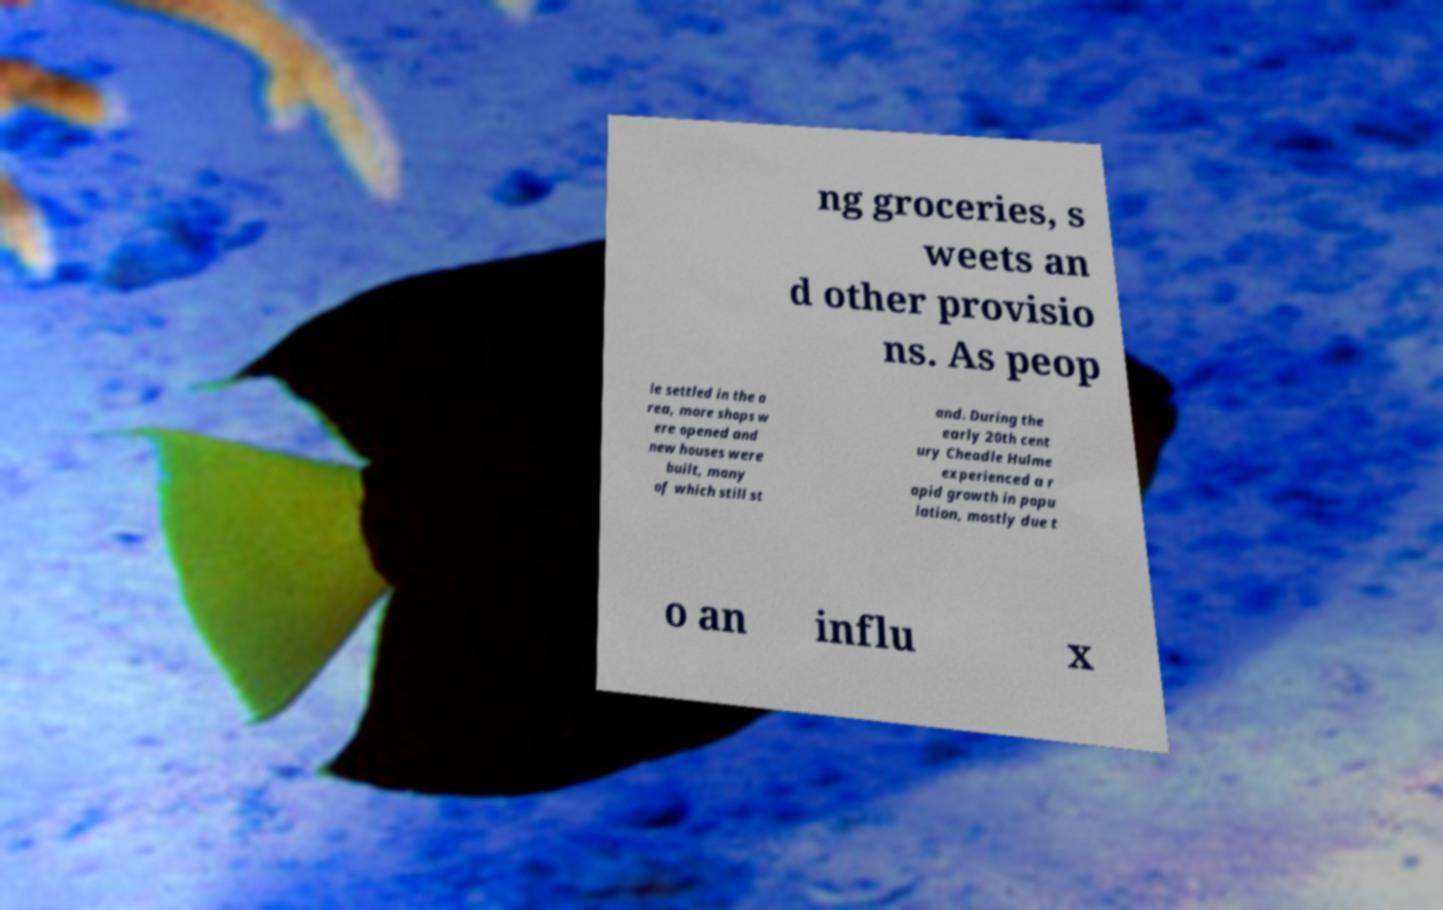There's text embedded in this image that I need extracted. Can you transcribe it verbatim? ng groceries, s weets an d other provisio ns. As peop le settled in the a rea, more shops w ere opened and new houses were built, many of which still st and. During the early 20th cent ury Cheadle Hulme experienced a r apid growth in popu lation, mostly due t o an influ x 